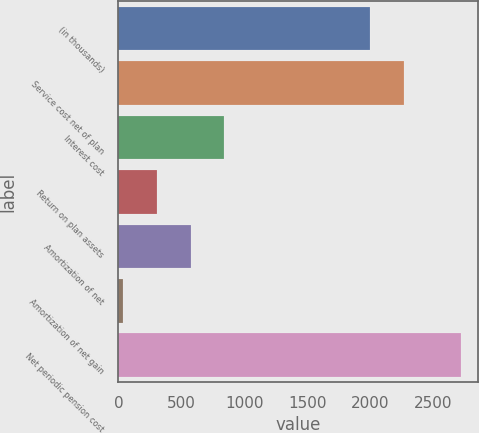<chart> <loc_0><loc_0><loc_500><loc_500><bar_chart><fcel>(in thousands)<fcel>Service cost net of plan<fcel>Interest cost<fcel>Return on plan assets<fcel>Amortization of net<fcel>Amortization of net gain<fcel>Net periodic pension cost<nl><fcel>2004<fcel>2272.5<fcel>842.5<fcel>305.5<fcel>574<fcel>37<fcel>2722<nl></chart> 